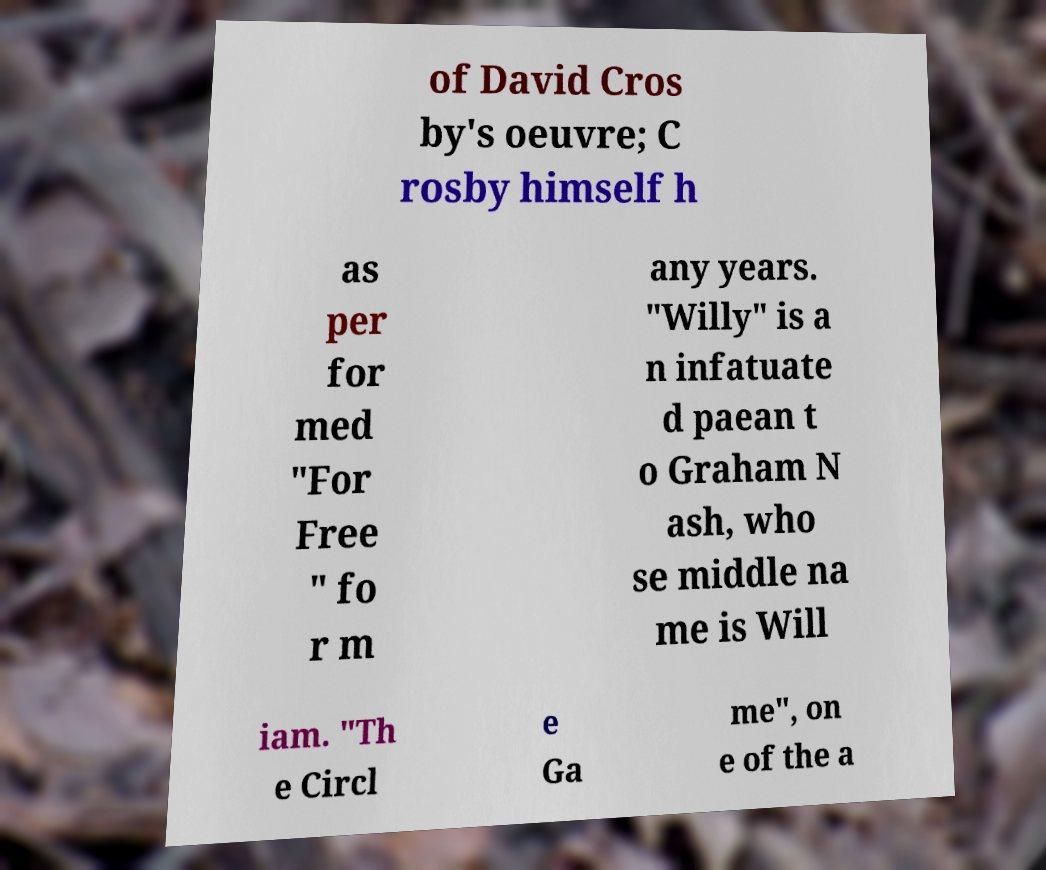Please read and relay the text visible in this image. What does it say? of David Cros by's oeuvre; C rosby himself h as per for med "For Free " fo r m any years. "Willy" is a n infatuate d paean t o Graham N ash, who se middle na me is Will iam. "Th e Circl e Ga me", on e of the a 